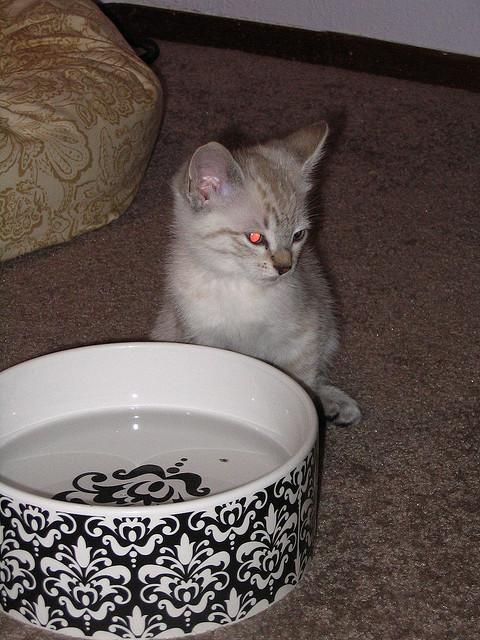What type of cat is this?
Short answer required. Kitten. Is this bowl too big for the kitten?
Quick response, please. Yes. What is the cat sitting on?
Be succinct. Carpet. Does the bowl match the carpeting?
Answer briefly. No. What type of object is this?
Concise answer only. Bowl. Why are the cat's eyes red?
Short answer required. Camera flash. What's painted on the bowl?
Be succinct. Designs. 